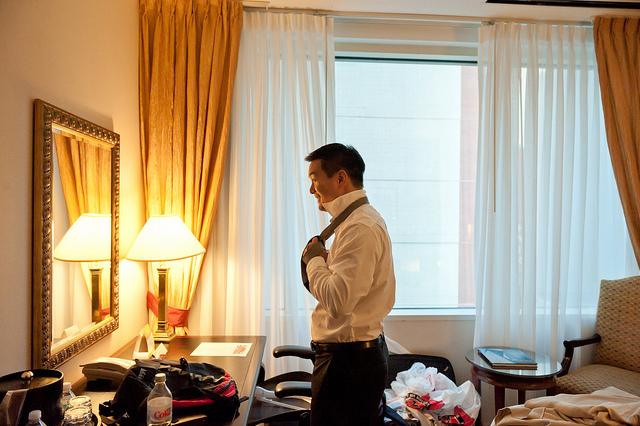Why the light is on?
Concise answer only. To see. What kind of room is the man in?
Short answer required. Hotel. Why is the man looking in the mirror?
Keep it brief. Tying tie. 